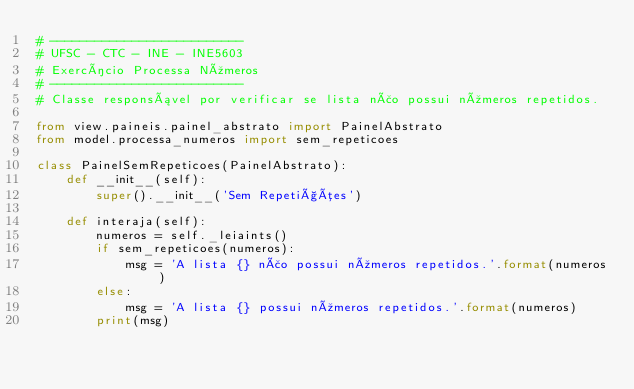<code> <loc_0><loc_0><loc_500><loc_500><_Python_># --------------------------
# UFSC - CTC - INE - INE5603
# Exercício Processa Números
# --------------------------
# Classe responsável por verificar se lista não possui números repetidos.

from view.paineis.painel_abstrato import PainelAbstrato
from model.processa_numeros import sem_repeticoes

class PainelSemRepeticoes(PainelAbstrato):
    def __init__(self):
        super().__init__('Sem Repetições')

    def interaja(self):
        numeros = self._leiaints()
        if sem_repeticoes(numeros):
            msg = 'A lista {} não possui números repetidos.'.format(numeros)
        else:
            msg = 'A lista {} possui números repetidos.'.format(numeros)
        print(msg)
</code> 